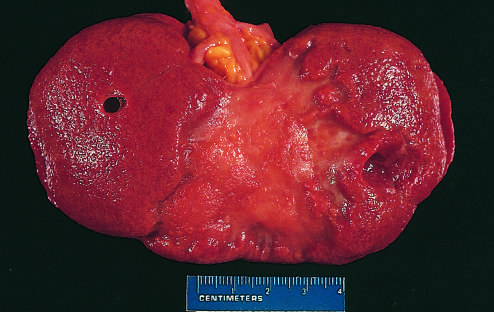what is the remote kidney infarct replaced by?
Answer the question using a single word or phrase. A large fibrotic scar 